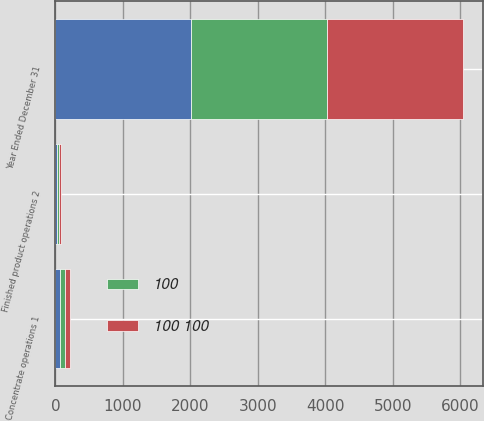Convert chart. <chart><loc_0><loc_0><loc_500><loc_500><stacked_bar_chart><ecel><fcel>Year Ended December 31<fcel>Concentrate operations 1<fcel>Finished product operations 2<nl><fcel>nan<fcel>2015<fcel>73<fcel>27<nl><fcel>100 100<fcel>2014<fcel>73<fcel>27<nl><fcel>100<fcel>2013<fcel>72<fcel>28<nl></chart> 